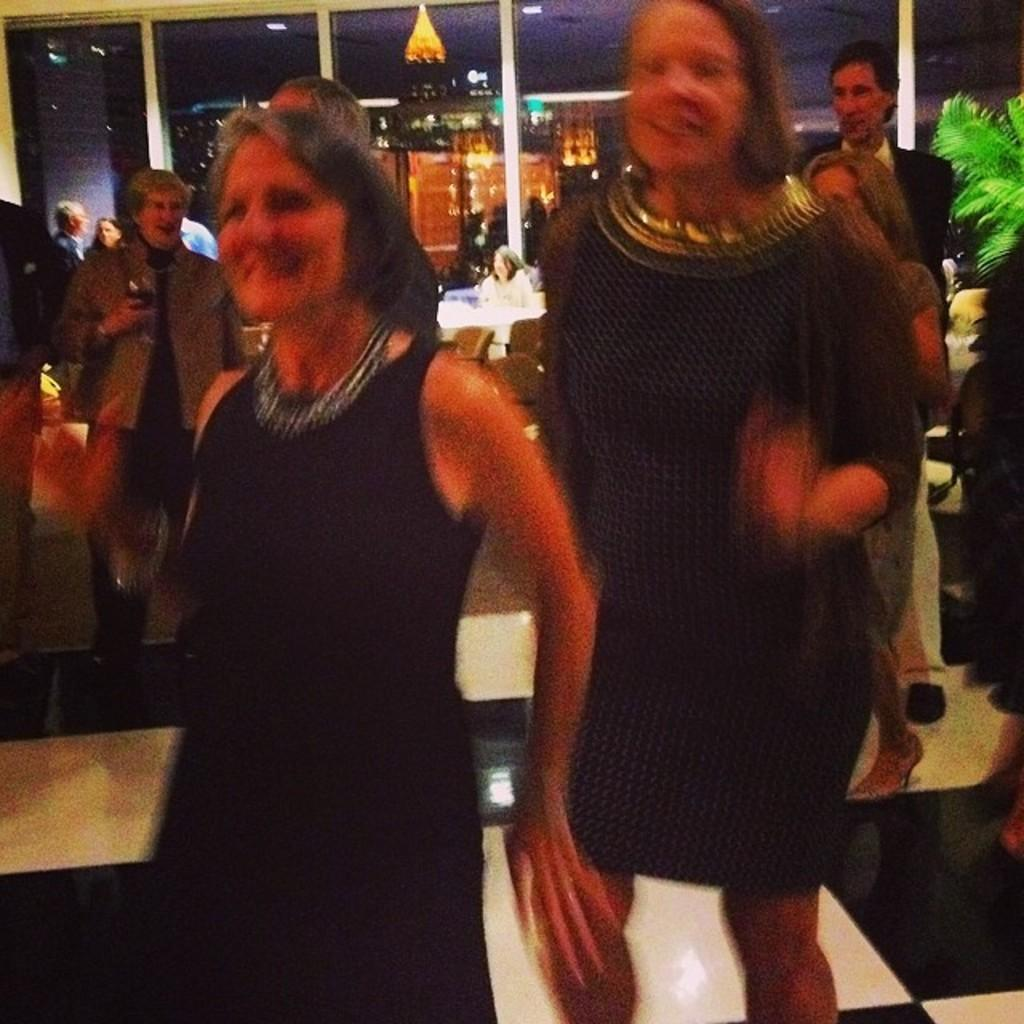What can be seen in the image involving multiple individuals? There is a group of people standing in the image. What type of vehicles are present in the image? There are cars in the image. What kind of plant is visible in the image? There is a house plant in the image. What architectural feature can be seen in the background of the image? There are glass doors in the background of the image. What type of straw is being used by the people in the image? There is no straw visible in the image. How many brothers are present in the image? The number of brothers cannot be determined from the image, as it does not provide information about familial relationships. 